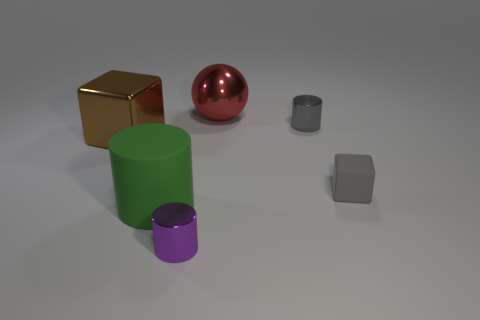What can you tell me about the lighting in this scene? The scene appears to be lit from the upper right, as indicated by the shadows cast by the objects on the surface to their lower left. The lighting seems diffused and soft, which prevents any harsh shadows and gives the image an even illumination. How does the lighting affect the appearance of the objects? The soft lighting reduces visual contrast and allows the inherent colors and textures of the objects to show through with minimal distortion. Additionally, it contributes to the perception of the objects' shapes by casting gentle, defining shadows. 